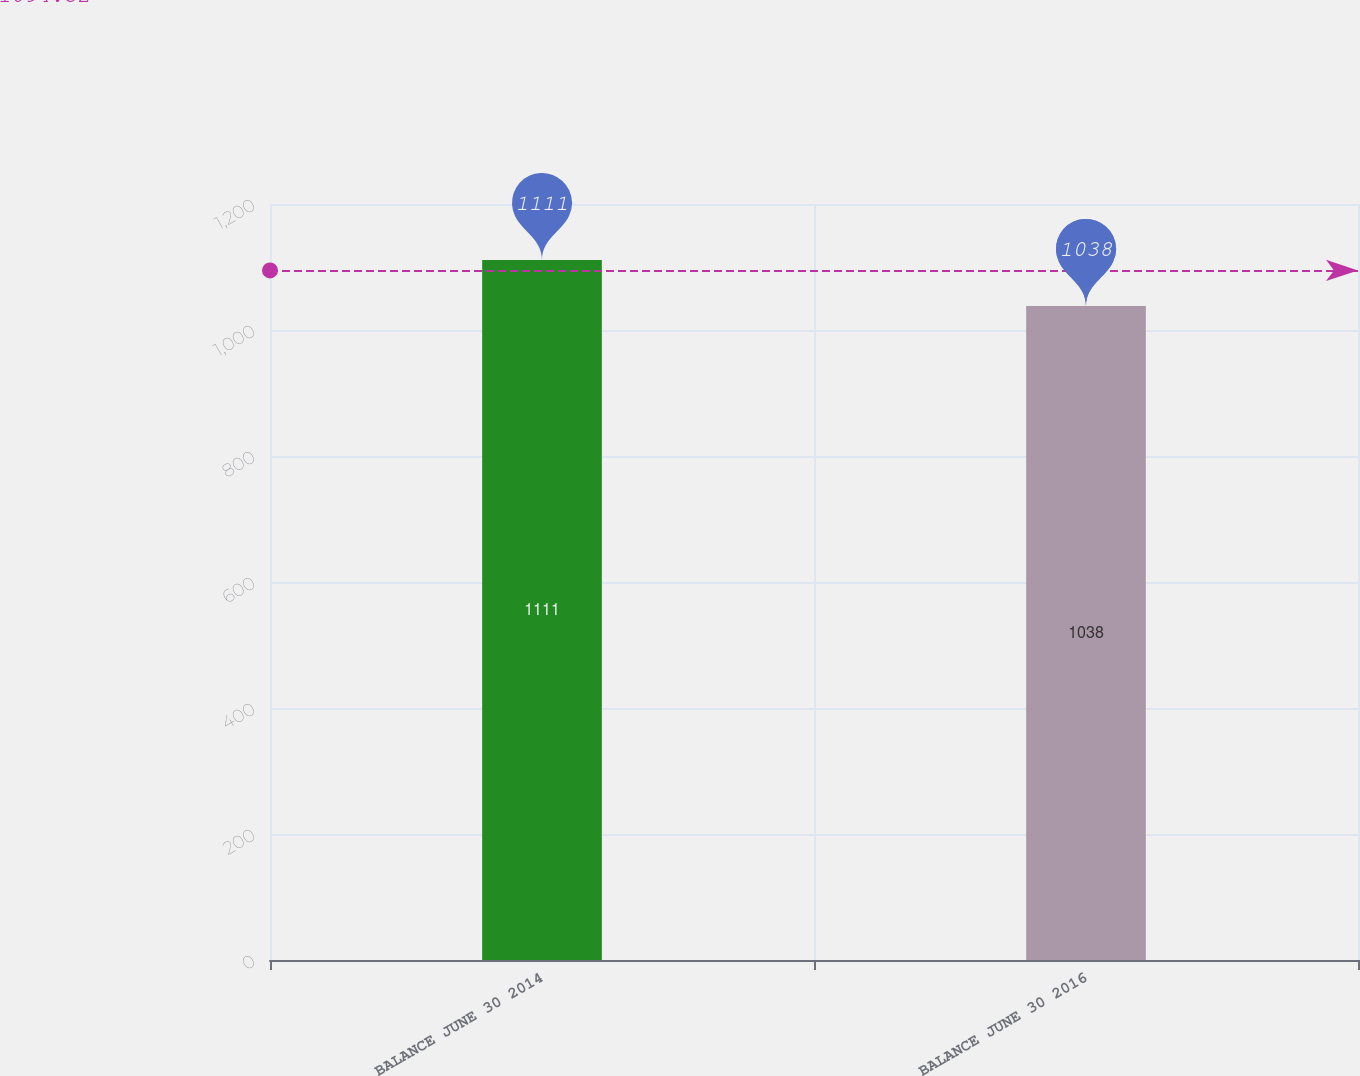<chart> <loc_0><loc_0><loc_500><loc_500><bar_chart><fcel>BALANCE JUNE 30 2014<fcel>BALANCE JUNE 30 2016<nl><fcel>1111<fcel>1038<nl></chart> 